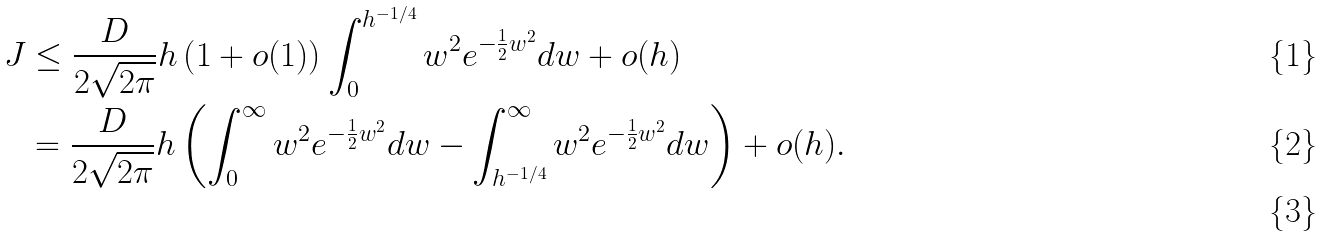Convert formula to latex. <formula><loc_0><loc_0><loc_500><loc_500>J & \leq \frac { D } { 2 \sqrt { 2 \pi } } h \left ( 1 + o ( 1 ) \right ) \int _ { 0 } ^ { h ^ { - 1 / 4 } } w ^ { 2 } e ^ { - \frac { 1 } { 2 } w ^ { 2 } } d w + o ( h ) \\ & = \frac { D } { 2 \sqrt { 2 \pi } } h \left ( \int _ { 0 } ^ { \infty } w ^ { 2 } e ^ { - \frac { 1 } { 2 } w ^ { 2 } } d w - \int _ { h ^ { - 1 / 4 } } ^ { \infty } w ^ { 2 } e ^ { - \frac { 1 } { 2 } w ^ { 2 } } d w \right ) + o ( h ) . \\</formula> 